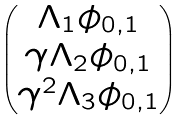<formula> <loc_0><loc_0><loc_500><loc_500>\begin{pmatrix} \Lambda _ { 1 } \phi _ { 0 , 1 } \\ \gamma \Lambda _ { 2 } \phi _ { 0 , 1 } \\ \gamma ^ { 2 } \Lambda _ { 3 } \phi _ { 0 , 1 } \end{pmatrix}</formula> 